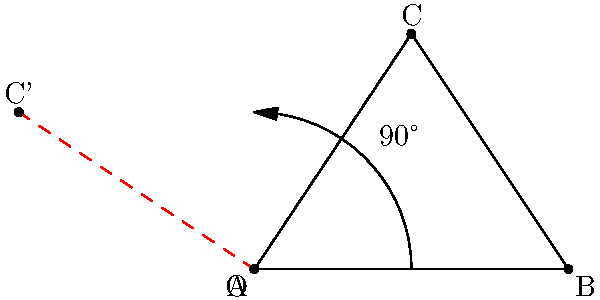In an investigation into the ethical implications of data privacy, you're analyzing a geometric model. Consider a right-angled triangle ABC with vertices A(0,0), B(4,0), and C(2,3). If this triangle is rotated 90° counterclockwise around the origin O(0,0), what are the coordinates of the rotated point C'? To solve this problem, we'll follow these steps:

1) The rotation of a point (x,y) by 90° counterclockwise around the origin is given by the formula:
   $$(x', y') = (-y, x)$$

2) The original coordinates of point C are (2,3).

3) Applying the rotation formula:
   $$x' = -y = -3$$
   $$y' = x = 2$$

4) Therefore, the new coordinates of C' after rotation are (-3,2).

This rotation transformation preserves the shape and size of the triangle while changing its orientation, much like how ethical journalism should present facts without distortion.
Answer: C'(-3,2) 